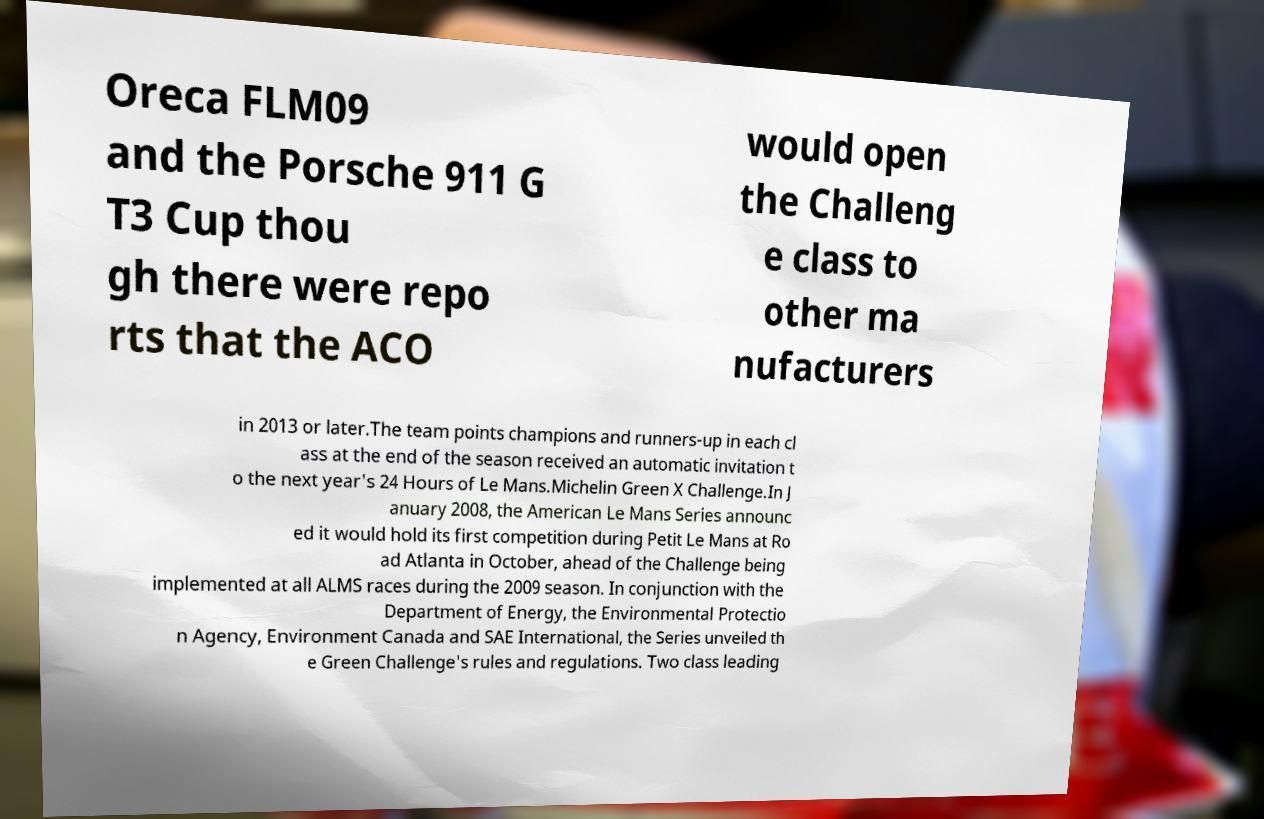Could you extract and type out the text from this image? Oreca FLM09 and the Porsche 911 G T3 Cup thou gh there were repo rts that the ACO would open the Challeng e class to other ma nufacturers in 2013 or later.The team points champions and runners-up in each cl ass at the end of the season received an automatic invitation t o the next year's 24 Hours of Le Mans.Michelin Green X Challenge.In J anuary 2008, the American Le Mans Series announc ed it would hold its first competition during Petit Le Mans at Ro ad Atlanta in October, ahead of the Challenge being implemented at all ALMS races during the 2009 season. In conjunction with the Department of Energy, the Environmental Protectio n Agency, Environment Canada and SAE International, the Series unveiled th e Green Challenge's rules and regulations. Two class leading 